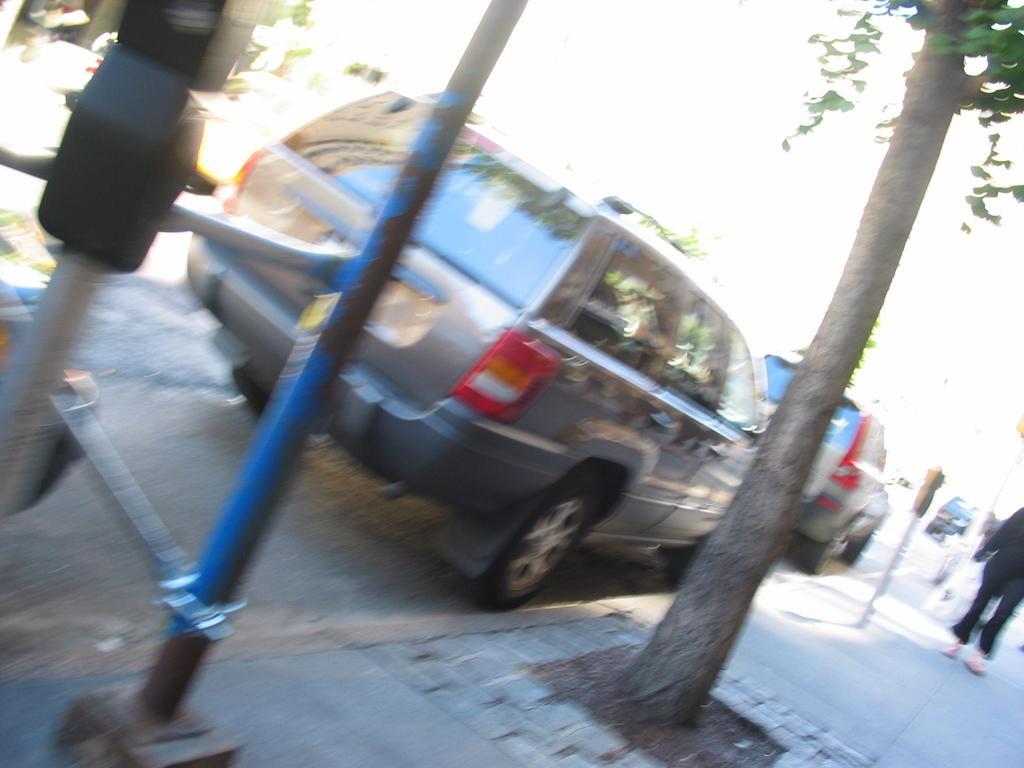Please provide a concise description of this image. Here in this picture we can see a couple of cars present on the road over there and we can see people walking on the side walk, we can also see parking meters, trees and traffic signal lights on the pole over there. 